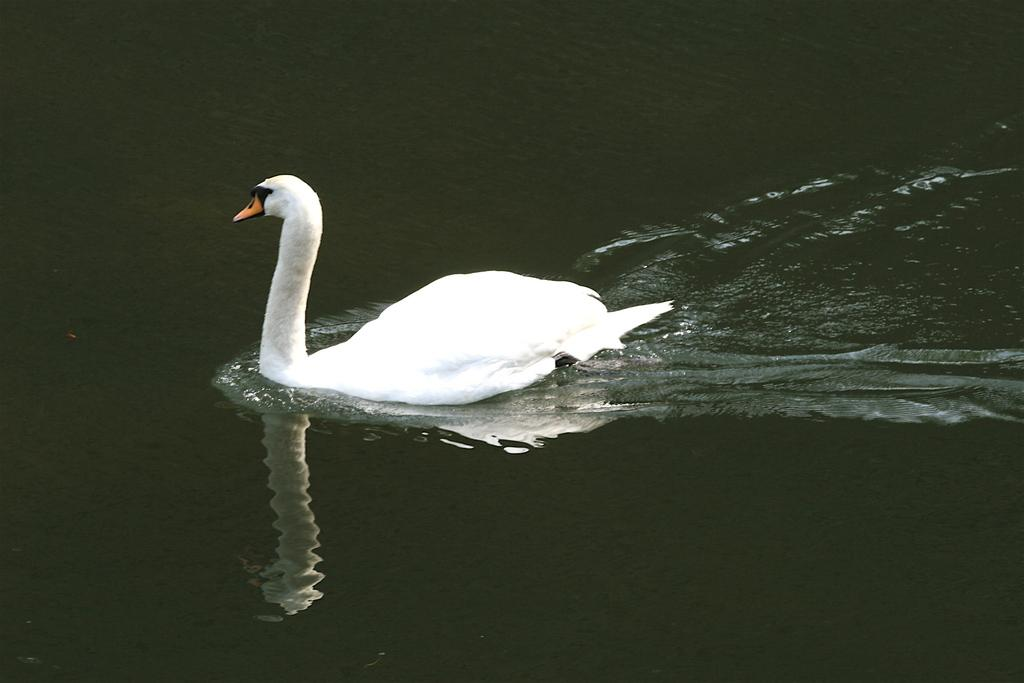What type of animal is in the image? There is a white color bird in the image. What is the bird doing in the image? The bird is swimming on the water. Can you describe the reflection of the bird in the water? There is a mirror image of the bird in the water. What is the color of the background in the image? The background of the image is dark in color. How many horses can be seen grazing in the bushes in the image? There are no horses or bushes present in the image; it features a white color bird swimming on the water with a dark background. 